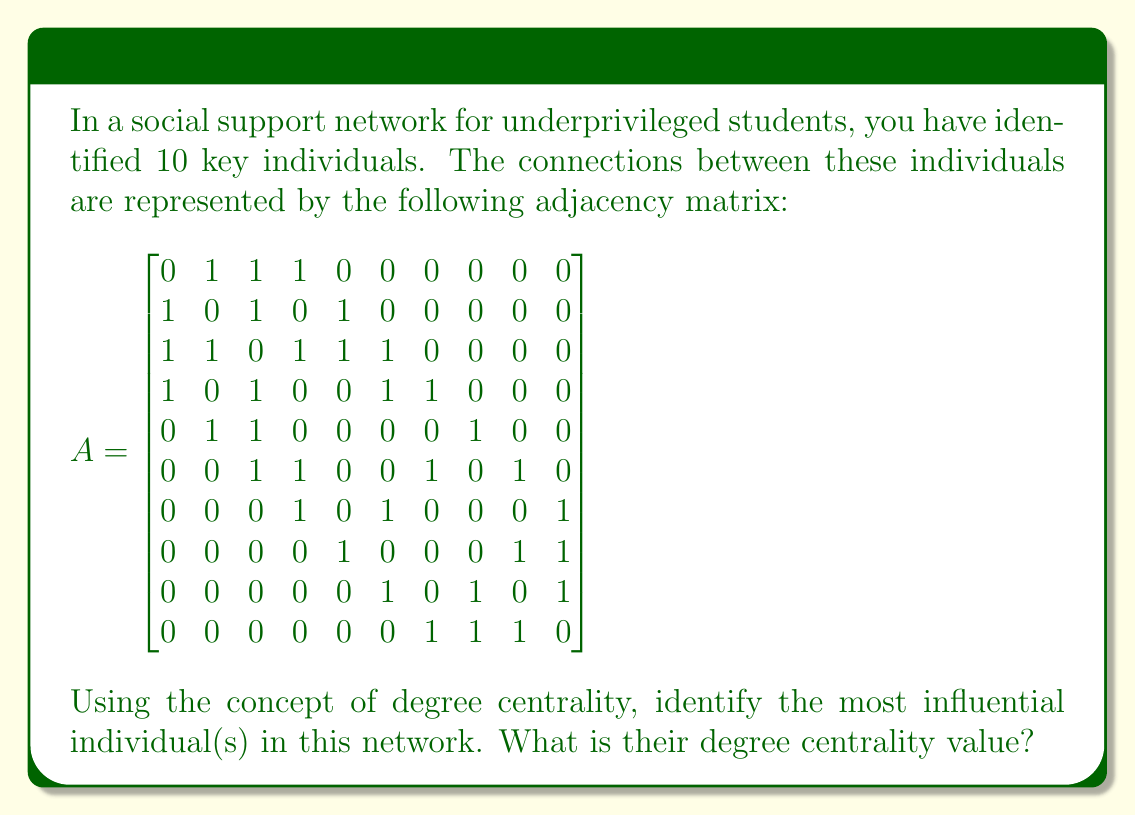Help me with this question. To solve this problem, we need to understand and apply the concept of degree centrality in graph theory:

1. Degree centrality is a measure of the number of direct connections an individual has in a network.

2. In an undirected graph (which this adjacency matrix represents), the degree centrality of a node is simply the sum of its connections.

3. To find the degree centrality for each individual, we need to sum the values in each row (or column, since the matrix is symmetric) of the adjacency matrix.

Let's calculate the degree centrality for each individual:

Individual 1: $1 + 1 + 1 + 0 + 0 + 0 + 0 + 0 + 0 = 3$
Individual 2: $1 + 1 + 0 + 1 + 0 + 0 + 0 + 0 + 0 = 3$
Individual 3: $1 + 1 + 1 + 1 + 1 + 0 + 0 + 0 + 0 = 5$
Individual 4: $1 + 0 + 1 + 0 + 1 + 1 + 0 + 0 + 0 = 4$
Individual 5: $0 + 1 + 1 + 0 + 0 + 0 + 1 + 0 + 0 = 3$
Individual 6: $0 + 0 + 1 + 1 + 0 + 1 + 0 + 1 + 0 = 4$
Individual 7: $0 + 0 + 0 + 1 + 0 + 1 + 0 + 0 + 1 = 3$
Individual 8: $0 + 0 + 0 + 0 + 1 + 0 + 0 + 1 + 1 = 3$
Individual 9: $0 + 0 + 0 + 0 + 0 + 1 + 0 + 1 + 1 = 3$
Individual 10: $0 + 0 + 0 + 0 + 0 + 0 + 1 + 1 + 1 = 3$

The highest degree centrality value is 5, corresponding to Individual 3.
Answer: The most influential individual is Individual 3, with a degree centrality value of 5. 